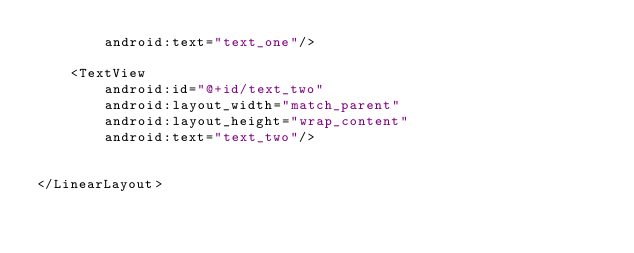Convert code to text. <code><loc_0><loc_0><loc_500><loc_500><_XML_>        android:text="text_one"/>

    <TextView
        android:id="@+id/text_two"
        android:layout_width="match_parent"
        android:layout_height="wrap_content"
        android:text="text_two"/>


</LinearLayout></code> 